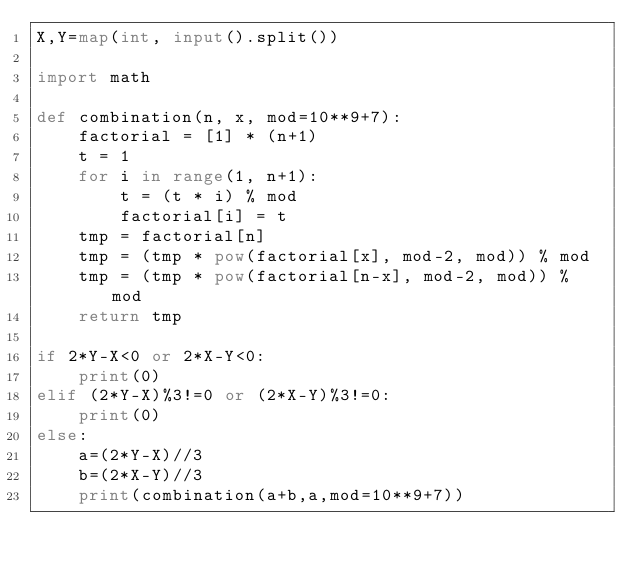Convert code to text. <code><loc_0><loc_0><loc_500><loc_500><_Python_>X,Y=map(int, input().split())

import math

def combination(n, x, mod=10**9+7):
    factorial = [1] * (n+1)
    t = 1
    for i in range(1, n+1):
        t = (t * i) % mod
        factorial[i] = t
    tmp = factorial[n]
    tmp = (tmp * pow(factorial[x], mod-2, mod)) % mod
    tmp = (tmp * pow(factorial[n-x], mod-2, mod)) % mod
    return tmp

if 2*Y-X<0 or 2*X-Y<0:
	print(0)
elif (2*Y-X)%3!=0 or (2*X-Y)%3!=0:
	print(0)
else:
	a=(2*Y-X)//3
	b=(2*X-Y)//3
	print(combination(a+b,a,mod=10**9+7))
</code> 